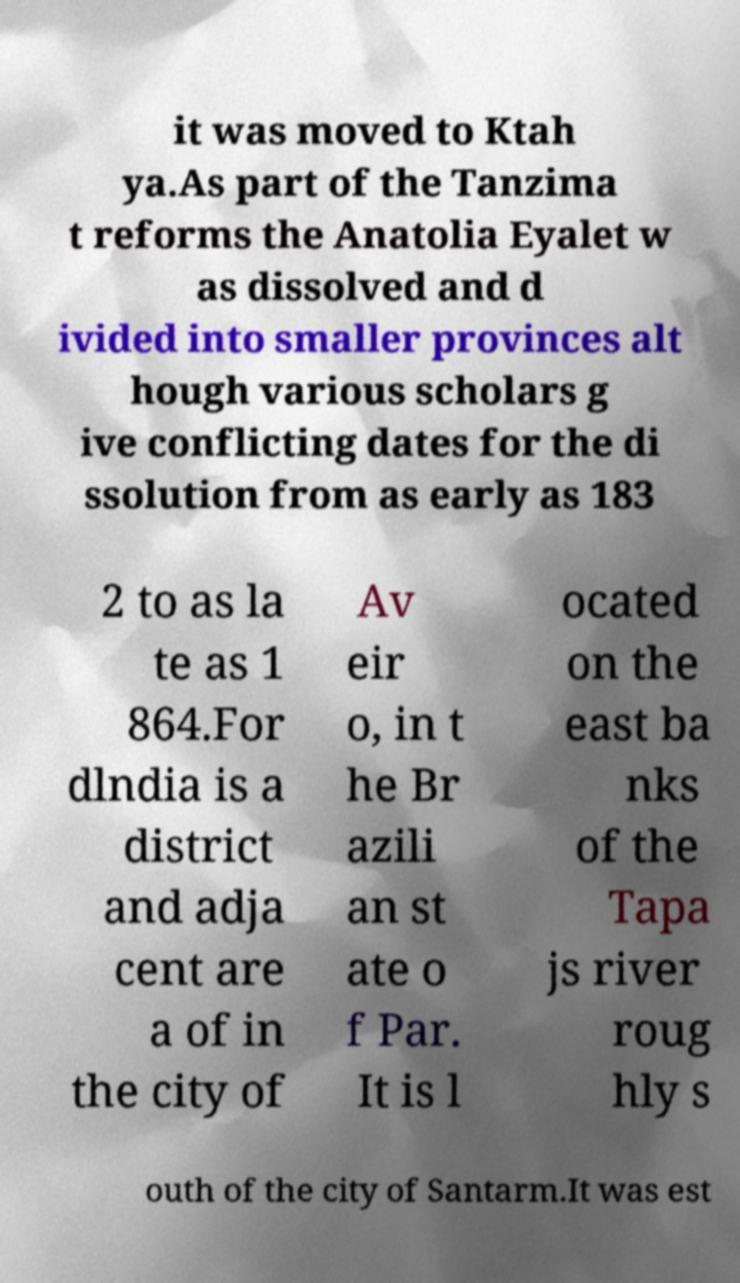There's text embedded in this image that I need extracted. Can you transcribe it verbatim? it was moved to Ktah ya.As part of the Tanzima t reforms the Anatolia Eyalet w as dissolved and d ivided into smaller provinces alt hough various scholars g ive conflicting dates for the di ssolution from as early as 183 2 to as la te as 1 864.For dlndia is a district and adja cent are a of in the city of Av eir o, in t he Br azili an st ate o f Par. It is l ocated on the east ba nks of the Tapa js river roug hly s outh of the city of Santarm.It was est 